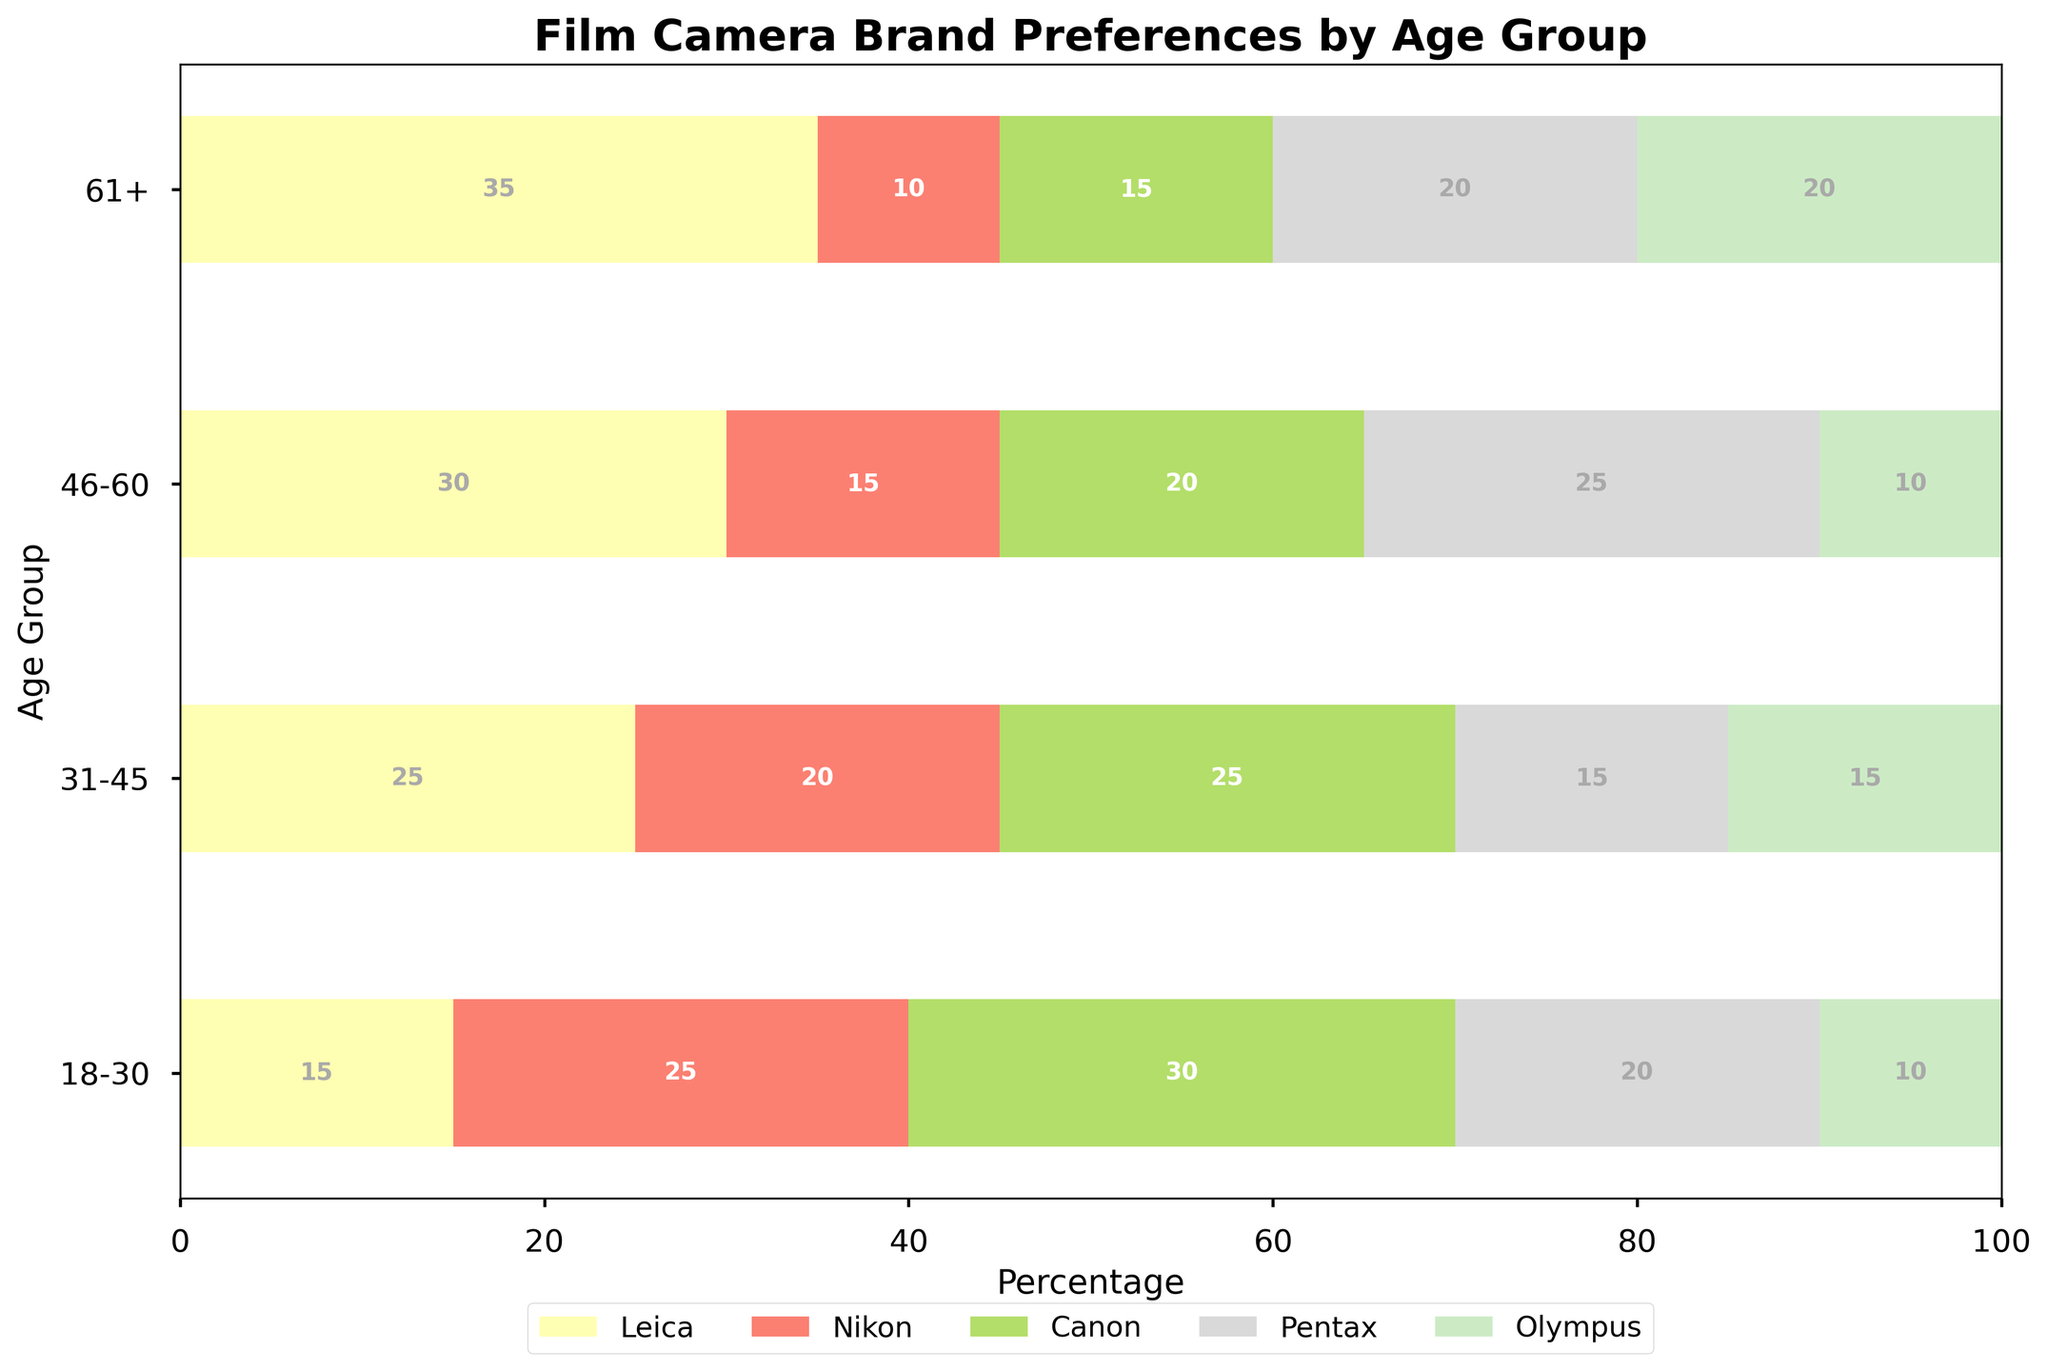What are the age groups represented in the mosaic plot? The x-axis of the mosaic plot lists the age groups, which are '18-30', '31-45', '46-60', and '61+'.
Answer: '18-30', '31-45', '46-60', '61+' Which film camera brand is most preferred by the '61+' age group? The '61+' age group's bar section with the most width represents the most preferred brand. The widest section belongs to Leica.
Answer: Leica What percentage of the '46-60' age group prefers Nikon? To find this, look at the Nikon segment in the bar for the '46-60' age group. The label in the Nikon segment shows '15', representing 15%.
Answer: 15% Which age group prefers Pentax the least? Compare the widths of the Pentax sections across all age groups. The '31-45' age group has the smallest Pentax section.
Answer: 31-45 How many age groups have more than 10% preference for Olympus? Check each age group's Olympus section to see if the width is above 10%. All four age groups ('18-30', '31-45', '46-60', '61+') have an Olympus preference greater than 10%.
Answer: 4 What is the total percentage of Canon preference for the '18-30' and '31-45' age groups combined? Sum the percentages of Canon preference in the '18-30' and '31-45' age groups: 30% (18-30) + 25% (31-45) = 55%.
Answer: 55% Which age group has the highest preference for Canon cameras? Look at the widths of the Canon sections across all age groups. The '18-30' age group has the widest Canon section, indicating the highest preference.
Answer: 18-30 What is the difference in percentage preference for Leica between the '18-30' and '61+' age groups? Subtract the Leica preference in the '18-30' age group (15%) from the Leica preference in the '61+' age group (35%): 35% - 15% = 20%.
Answer: 20% Are there any age groups where the preference for a brand is equal to 20%? Check all brand sections to see if any percentages align with 20%. The '18-30' age group for Pentax, '46-60' age group for Canon, '61+' age group for Pentax, and '61+' age group for Olympus each have a preference of 20%.
Answer: Yes Which age group shows the most balanced preferences among the five brands? Assess the evenness in the widths of the preference sections for each age group. The '31-45' age group's sections appear the most balanced across all brands.
Answer: 31-45 